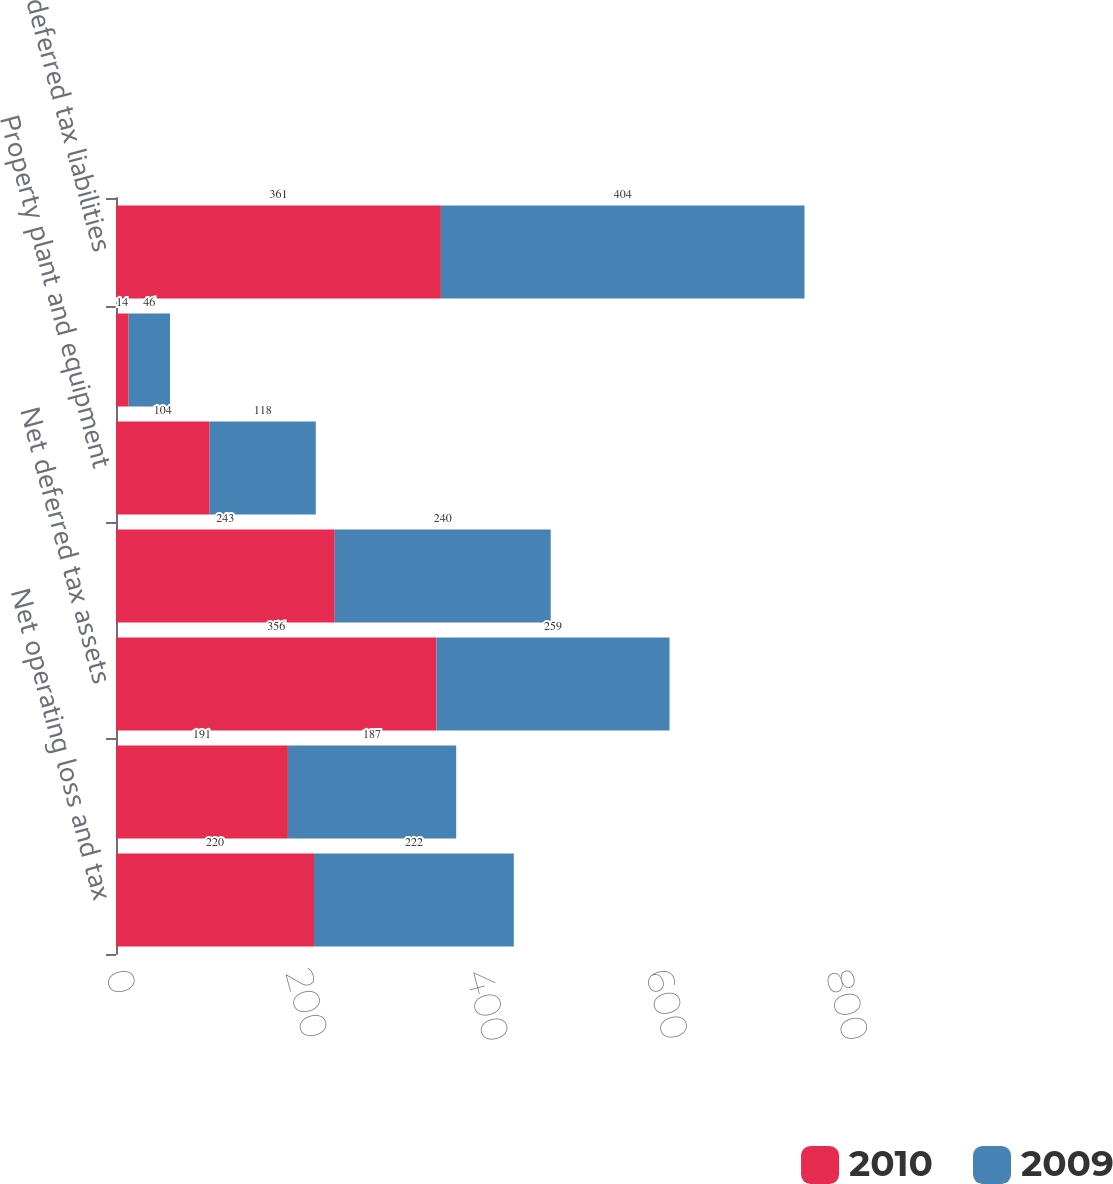<chart> <loc_0><loc_0><loc_500><loc_500><stacked_bar_chart><ecel><fcel>Net operating loss and tax<fcel>Deferred tax asset valuation<fcel>Net deferred tax assets<fcel>Intangible assets including<fcel>Property plant and equipment<fcel>Other<fcel>Gross deferred tax liabilities<nl><fcel>2010<fcel>220<fcel>191<fcel>356<fcel>243<fcel>104<fcel>14<fcel>361<nl><fcel>2009<fcel>222<fcel>187<fcel>259<fcel>240<fcel>118<fcel>46<fcel>404<nl></chart> 